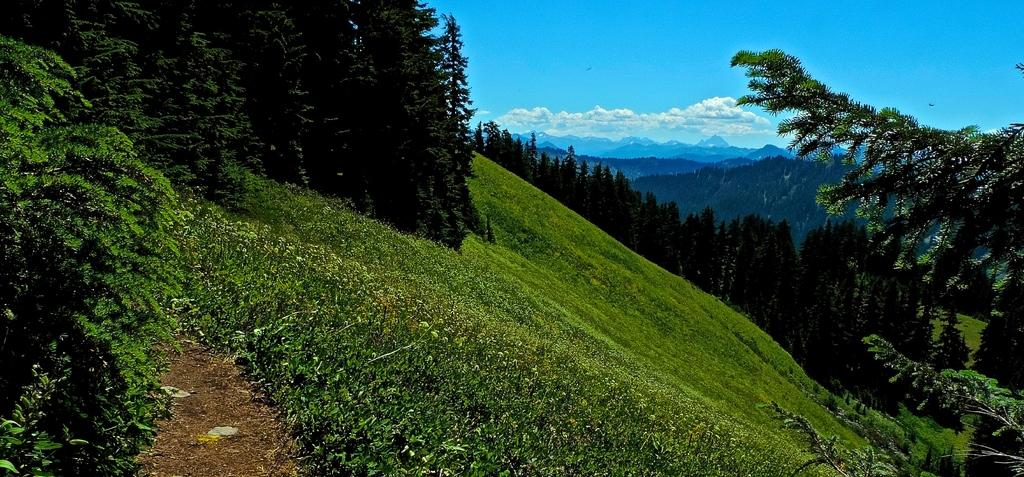What type of vegetation can be seen in the image? There are trees and plants in the image. What geographical feature is visible in the image? There are mountains in the image. What type of ground cover is present in the image? There is grass in the image. What can be seen in the background of the image? The sky is visible in the background of the image. What atmospheric conditions can be observed in the sky? Clouds are present in the sky. Can you tell me where the aunt is skating in the image? There is no aunt or skating activity present in the image. What type of sidewalk can be seen in the image? There is no sidewalk present in the image. 